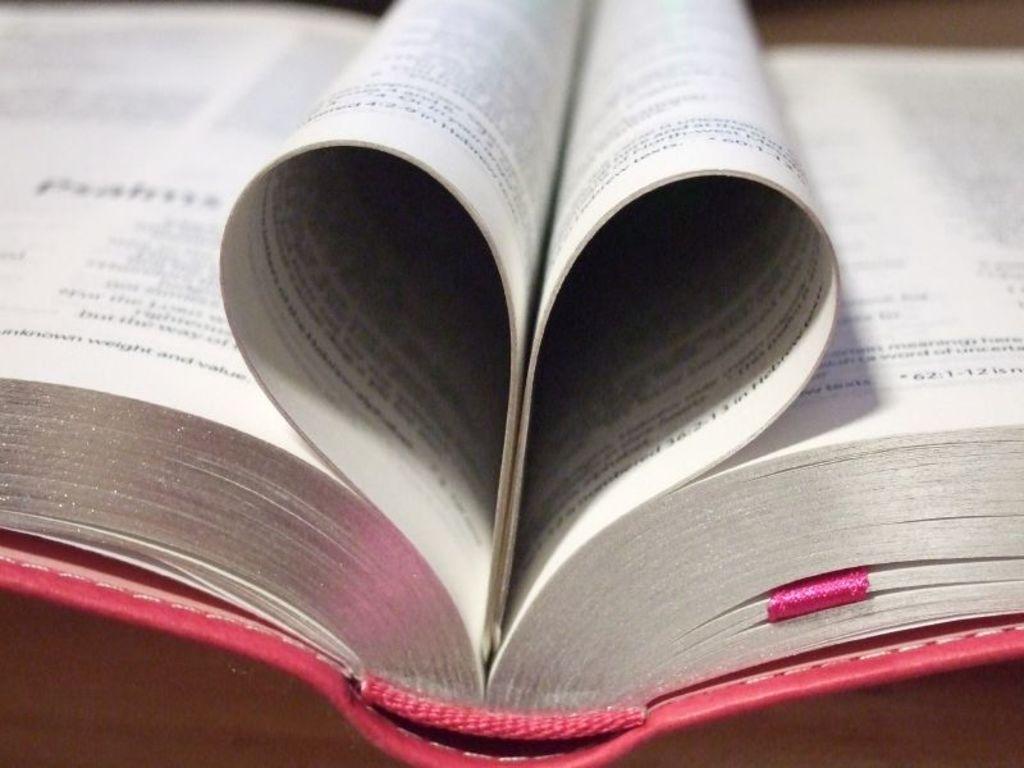What numbers are on the bottom of the right page?
Make the answer very short. 62:1-12. 